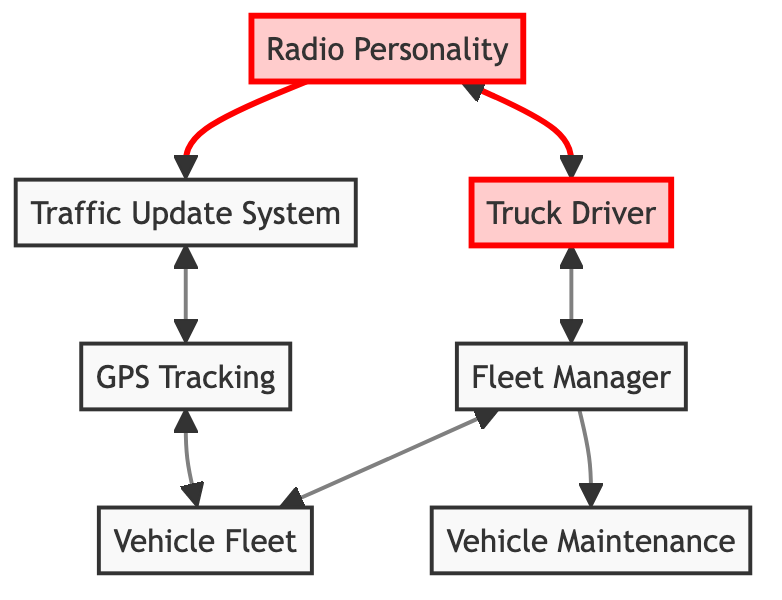What is the role of the Truck Driver? The Truck Driver functions as a field reporter who provides traffic updates. This is directly stated in the description of the Truck Driver block in the diagram.
Answer: Field reporter How many connections does the Radio Personality have? The Radio Personality connects to two other blocks in the diagram: the Traffic Update System and the Truck Driver. Counting these connections gives the answer.
Answer: 2 What directly connects the Truck Driver and Fleet Manager? The Truck Driver is directly connected to the Fleet Manager, meaning they have a direct link in the flow of the diagram. This is evident in the connections specified.
Answer: Truck Driver Which block oversees vehicle maintenance? The Fleet Manager block is responsible for overseeing vehicle maintenance, as described in its description. Thus, the Fleet Manager directly relates to vehicle maintenance.
Answer: Fleet Manager How many blocks are responsible for collecting traffic data? The Traffic Update System is the main block responsible for collecting and processing traffic data, as indicated by its role in the diagram. There is only one block tasked with this function.
Answer: 1 What connects the Vehicle Fleet to the GPS Tracking? The connection between the Vehicle Fleet and GPS Tracking is bidirectional, which shows that they exchange information about the location of vehicles. This link can be identified in the connections of both blocks.
Answer: GPS Tracking Which roles does the Traffic Update System interact with? The Traffic Update System interacts with both the Radio Personality and GPS Tracking, indicated by the connections shown in the diagram.
Answer: Radio Personality and GPS Tracking What is the relationship between the Fleet Manager and Vehicle Maintenance? The Fleet Manager has a direct connection that indicates oversight over Vehicle Maintenance, signifying that the Fleet Manager is responsible for the maintenance of the fleet.
Answer: Oversight How does data flow from the Truck Driver to the Radio Personality? Data flows from the Truck Driver to the Radio Personality directly, indicating that the Truck Driver provides traffic information that is then relayed by the Radio Personality on-air.
Answer: Directly 